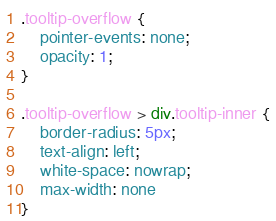Convert code to text. <code><loc_0><loc_0><loc_500><loc_500><_CSS_>.tooltip-overflow {
	pointer-events: none;
	opacity: 1;
}

.tooltip-overflow > div.tooltip-inner {
	border-radius: 5px;
	text-align: left;
	white-space: nowrap;
	max-width: none
}
</code> 